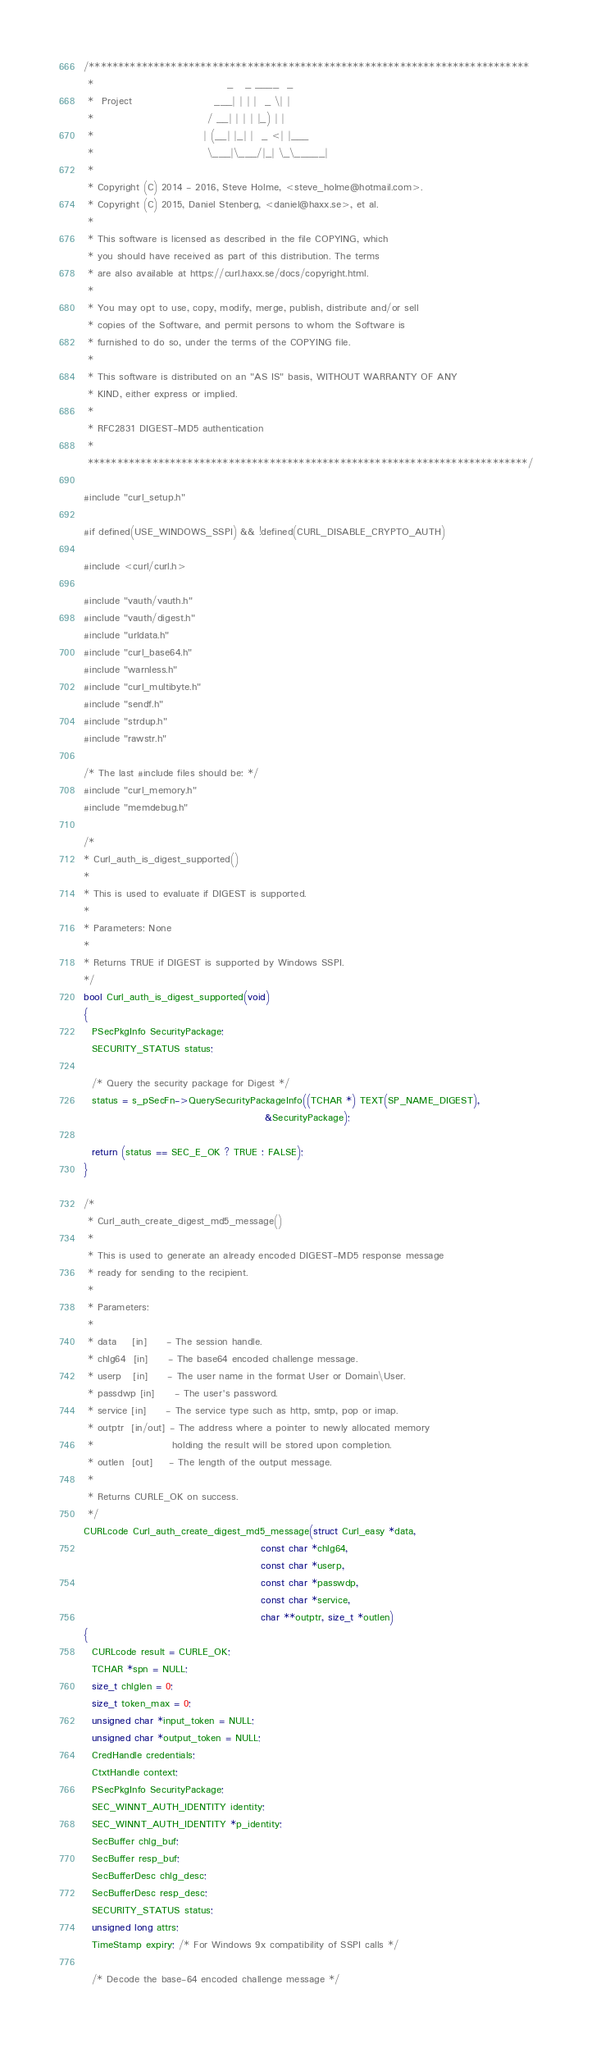<code> <loc_0><loc_0><loc_500><loc_500><_C_>/***************************************************************************
 *                                  _   _ ____  _
 *  Project                     ___| | | |  _ \| |
 *                             / __| | | | |_) | |
 *                            | (__| |_| |  _ <| |___
 *                             \___|\___/|_| \_\_____|
 *
 * Copyright (C) 2014 - 2016, Steve Holme, <steve_holme@hotmail.com>.
 * Copyright (C) 2015, Daniel Stenberg, <daniel@haxx.se>, et al.
 *
 * This software is licensed as described in the file COPYING, which
 * you should have received as part of this distribution. The terms
 * are also available at https://curl.haxx.se/docs/copyright.html.
 *
 * You may opt to use, copy, modify, merge, publish, distribute and/or sell
 * copies of the Software, and permit persons to whom the Software is
 * furnished to do so, under the terms of the COPYING file.
 *
 * This software is distributed on an "AS IS" basis, WITHOUT WARRANTY OF ANY
 * KIND, either express or implied.
 *
 * RFC2831 DIGEST-MD5 authentication
 *
 ***************************************************************************/

#include "curl_setup.h"

#if defined(USE_WINDOWS_SSPI) && !defined(CURL_DISABLE_CRYPTO_AUTH)

#include <curl/curl.h>

#include "vauth/vauth.h"
#include "vauth/digest.h"
#include "urldata.h"
#include "curl_base64.h"
#include "warnless.h"
#include "curl_multibyte.h"
#include "sendf.h"
#include "strdup.h"
#include "rawstr.h"

/* The last #include files should be: */
#include "curl_memory.h"
#include "memdebug.h"

/*
* Curl_auth_is_digest_supported()
*
* This is used to evaluate if DIGEST is supported.
*
* Parameters: None
*
* Returns TRUE if DIGEST is supported by Windows SSPI.
*/
bool Curl_auth_is_digest_supported(void)
{
  PSecPkgInfo SecurityPackage;
  SECURITY_STATUS status;

  /* Query the security package for Digest */
  status = s_pSecFn->QuerySecurityPackageInfo((TCHAR *) TEXT(SP_NAME_DIGEST),
                                              &SecurityPackage);

  return (status == SEC_E_OK ? TRUE : FALSE);
}

/*
 * Curl_auth_create_digest_md5_message()
 *
 * This is used to generate an already encoded DIGEST-MD5 response message
 * ready for sending to the recipient.
 *
 * Parameters:
 *
 * data    [in]     - The session handle.
 * chlg64  [in]     - The base64 encoded challenge message.
 * userp   [in]     - The user name in the format User or Domain\User.
 * passdwp [in]     - The user's password.
 * service [in]     - The service type such as http, smtp, pop or imap.
 * outptr  [in/out] - The address where a pointer to newly allocated memory
 *                    holding the result will be stored upon completion.
 * outlen  [out]    - The length of the output message.
 *
 * Returns CURLE_OK on success.
 */
CURLcode Curl_auth_create_digest_md5_message(struct Curl_easy *data,
                                             const char *chlg64,
                                             const char *userp,
                                             const char *passwdp,
                                             const char *service,
                                             char **outptr, size_t *outlen)
{
  CURLcode result = CURLE_OK;
  TCHAR *spn = NULL;
  size_t chlglen = 0;
  size_t token_max = 0;
  unsigned char *input_token = NULL;
  unsigned char *output_token = NULL;
  CredHandle credentials;
  CtxtHandle context;
  PSecPkgInfo SecurityPackage;
  SEC_WINNT_AUTH_IDENTITY identity;
  SEC_WINNT_AUTH_IDENTITY *p_identity;
  SecBuffer chlg_buf;
  SecBuffer resp_buf;
  SecBufferDesc chlg_desc;
  SecBufferDesc resp_desc;
  SECURITY_STATUS status;
  unsigned long attrs;
  TimeStamp expiry; /* For Windows 9x compatibility of SSPI calls */

  /* Decode the base-64 encoded challenge message */</code> 